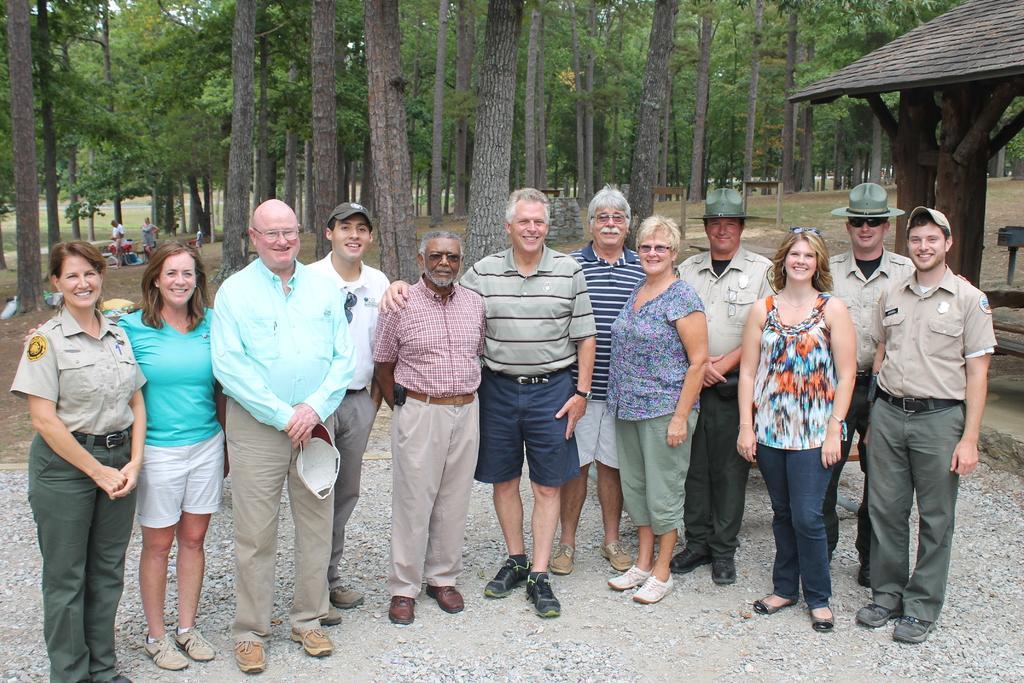Could you give a brief overview of what you see in this image? There are many people standing. Some are wearing hats and caps. One person is wearing specs and holding a cap. In the back there are many trees. On the right side there is a shed. In the background there are few people. 